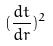Convert formula to latex. <formula><loc_0><loc_0><loc_500><loc_500>( \frac { d t } { d r } ) ^ { 2 }</formula> 